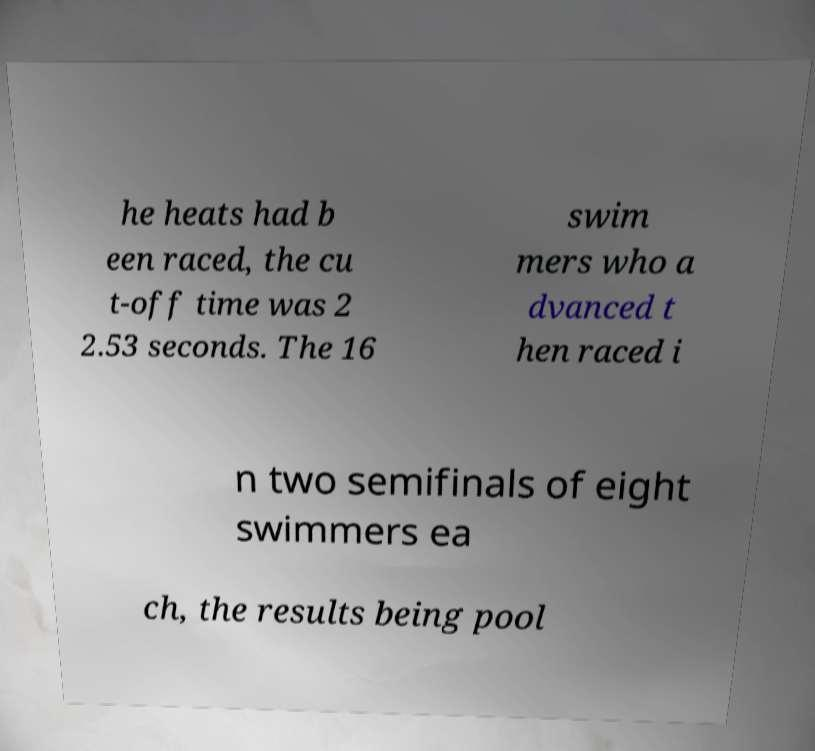Can you accurately transcribe the text from the provided image for me? he heats had b een raced, the cu t-off time was 2 2.53 seconds. The 16 swim mers who a dvanced t hen raced i n two semifinals of eight swimmers ea ch, the results being pool 